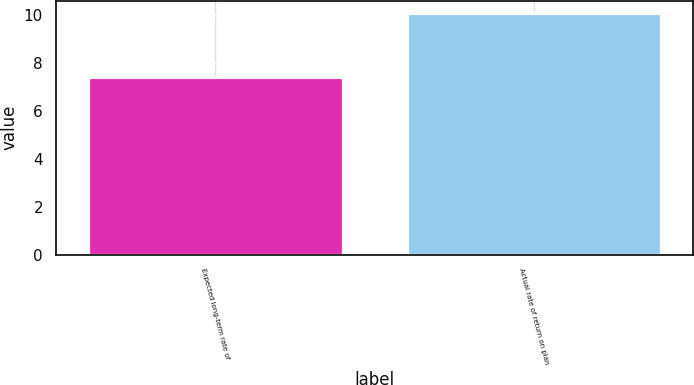<chart> <loc_0><loc_0><loc_500><loc_500><bar_chart><fcel>Expected long-term rate of<fcel>Actual rate of return on plan<nl><fcel>7.42<fcel>10.09<nl></chart> 